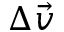<formula> <loc_0><loc_0><loc_500><loc_500>\Delta \vec { v }</formula> 